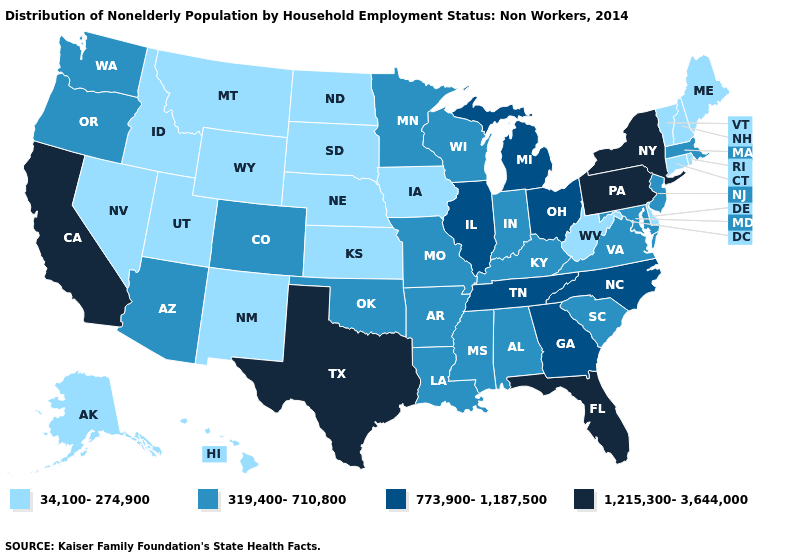What is the lowest value in states that border Arizona?
Give a very brief answer. 34,100-274,900. Name the states that have a value in the range 319,400-710,800?
Keep it brief. Alabama, Arizona, Arkansas, Colorado, Indiana, Kentucky, Louisiana, Maryland, Massachusetts, Minnesota, Mississippi, Missouri, New Jersey, Oklahoma, Oregon, South Carolina, Virginia, Washington, Wisconsin. Does Wyoming have a lower value than Maryland?
Keep it brief. Yes. Name the states that have a value in the range 34,100-274,900?
Write a very short answer. Alaska, Connecticut, Delaware, Hawaii, Idaho, Iowa, Kansas, Maine, Montana, Nebraska, Nevada, New Hampshire, New Mexico, North Dakota, Rhode Island, South Dakota, Utah, Vermont, West Virginia, Wyoming. Name the states that have a value in the range 34,100-274,900?
Keep it brief. Alaska, Connecticut, Delaware, Hawaii, Idaho, Iowa, Kansas, Maine, Montana, Nebraska, Nevada, New Hampshire, New Mexico, North Dakota, Rhode Island, South Dakota, Utah, Vermont, West Virginia, Wyoming. Does New York have the same value as California?
Short answer required. Yes. What is the highest value in the MidWest ?
Be succinct. 773,900-1,187,500. Among the states that border Connecticut , which have the lowest value?
Short answer required. Rhode Island. How many symbols are there in the legend?
Concise answer only. 4. Name the states that have a value in the range 1,215,300-3,644,000?
Be succinct. California, Florida, New York, Pennsylvania, Texas. Name the states that have a value in the range 773,900-1,187,500?
Write a very short answer. Georgia, Illinois, Michigan, North Carolina, Ohio, Tennessee. What is the value of Hawaii?
Concise answer only. 34,100-274,900. What is the lowest value in states that border Washington?
Concise answer only. 34,100-274,900. Does Georgia have the lowest value in the USA?
Short answer required. No. What is the highest value in the West ?
Give a very brief answer. 1,215,300-3,644,000. 